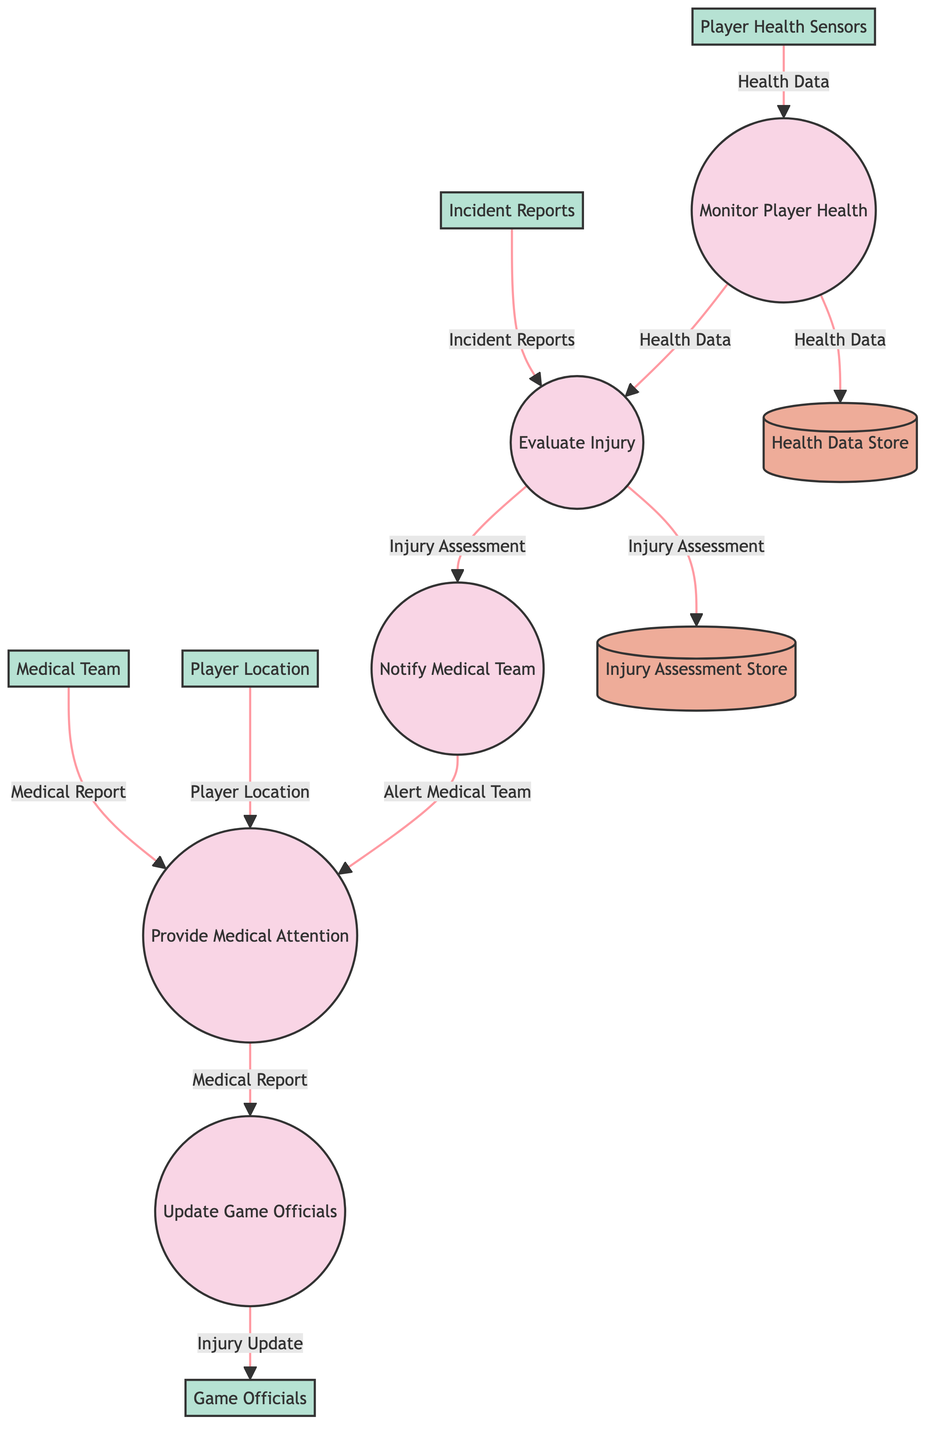What's the output of the "Monitor Player Health" process? The output of the "Monitor Player Health" process is "Health Data," which indicates that this process generates health-related information based on the input from player health sensors.
Answer: Health Data How many processes are represented in this diagram? The diagram contains five processes that are part of the real-time injury reporting and management system during games. These processes include monitoring, evaluating, notifying, providing attention, and updating officials.
Answer: Five What is the input to the "Evaluate Injury" process? The "Evaluate Injury" process has two inputs: "Health Data" and "Incident Reports." This means it requires both types of information to assess an injury accurately.
Answer: Health Data and Incident Reports Which process sends the output to the "Game Officials"? The "Update Game Officials" process sends the output defined as "Injury Update" to the Game Officials. Therefore, this process is responsible for informing game officials about the injury status.
Answer: Update Game Officials What data store is used to store the "Injury Assessment"? The data store responsible for keeping the "Injury Assessment" output is called the "Injury Assessment Store," which serves as a repository for injury evaluation data.
Answer: Injury Assessment Store Which external entity provides "Alert Medical Team" as an output? The "Notify Medical Team" process generates the output "Alert Medical Team," indicating it is responsible for informing the medical team about potential injuries based on assessments.
Answer: Notify Medical Team What is the relationship between "Medical Report" and "Provide Medical Attention"? The "Provide Medical Attention" process outputs "Medical Report," which signifies that providing medical attention should result in the creation of a medical report that captures what occurred during the incident and treatment.
Answer: Medical Report How many data flows are there in total? The diagram contains a total of ten data flows, which include the transmission of health data, incident reports, injury assessments, medical reports, and more across various processes and data stores.
Answer: Ten What information does the "Health Data Store" output? The "Health Data Store" simply outputs "Health Data," meaning it retains and can provide access to health information as needed by other processes in the system.
Answer: Health Data 